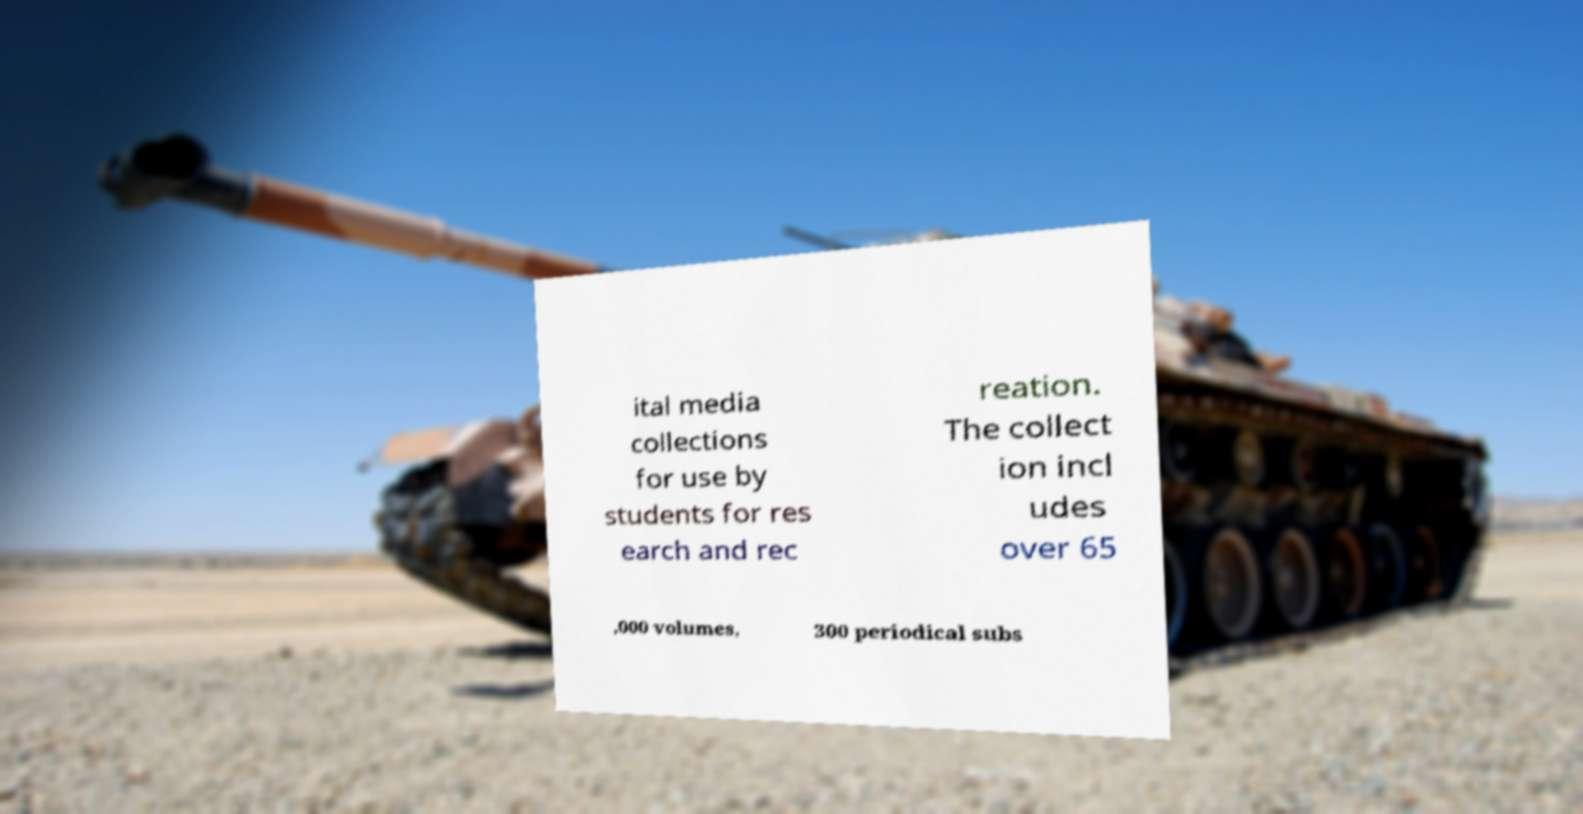Please read and relay the text visible in this image. What does it say? ital media collections for use by students for res earch and rec reation. The collect ion incl udes over 65 ,000 volumes, 300 periodical subs 